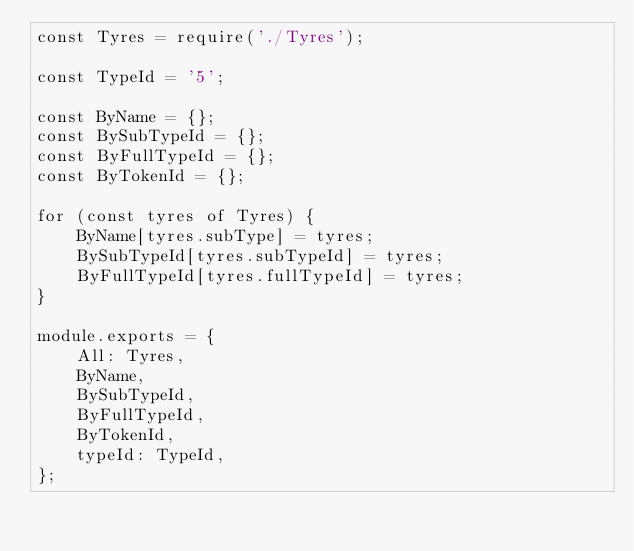<code> <loc_0><loc_0><loc_500><loc_500><_JavaScript_>const Tyres = require('./Tyres');

const TypeId = '5';

const ByName = {};
const BySubTypeId = {};
const ByFullTypeId = {};
const ByTokenId = {};

for (const tyres of Tyres) {
    ByName[tyres.subType] = tyres;
    BySubTypeId[tyres.subTypeId] = tyres;
    ByFullTypeId[tyres.fullTypeId] = tyres;
}

module.exports = {
    All: Tyres,
    ByName,
    BySubTypeId,
    ByFullTypeId,
    ByTokenId,
    typeId: TypeId,
};
</code> 